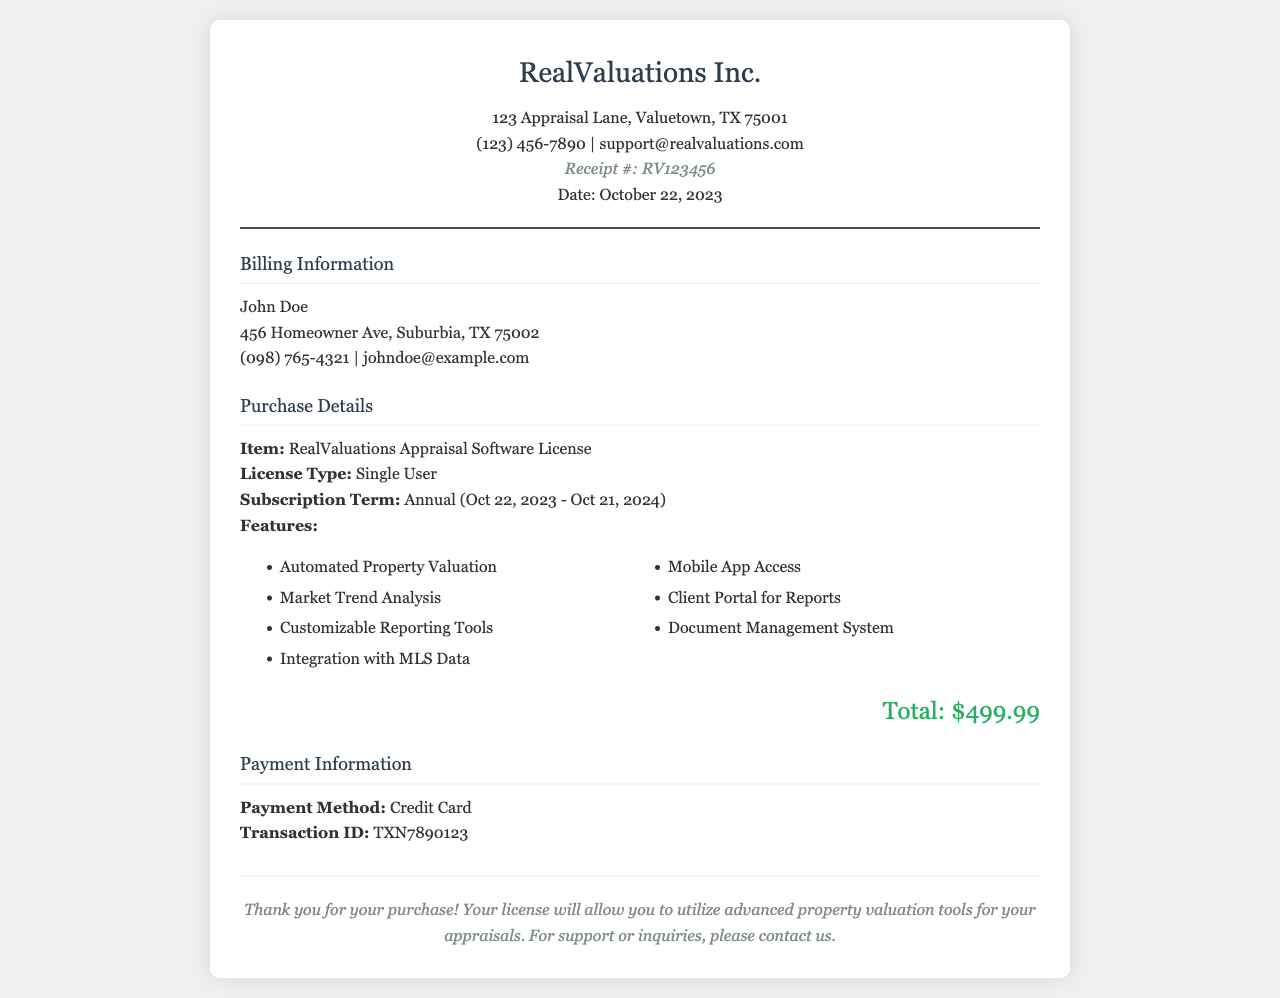What is the receipt number? The receipt number identifies the specific transaction within the company's records, which is RV123456.
Answer: RV123456 What is the total amount paid? The total amount paid shown in the document, representing the cost of the software license, is $499.99.
Answer: $499.99 Who is the billing information addressed to? The billing information lists the name of the individual responsible for the payment, which is John Doe.
Answer: John Doe What is the subscription term for the software? The subscription term defines the period for which the license is valid, stated as Annual (Oct 22, 2023 - Oct 21, 2024).
Answer: Annual (Oct 22, 2023 - Oct 21, 2024) What are the features included with the software? The features provide a list of functionalities available with the software license, including Automated Property Valuation and Market Trend Analysis.
Answer: Automated Property Valuation, Market Trend Analysis, Customizable Reporting Tools, Integration with MLS Data, Mobile App Access, Client Portal for Reports, Document Management System What payment method was used? The payment method indicates how the purchase was completed, specified as Credit Card in the document.
Answer: Credit Card What is the transaction ID? The transaction ID is a unique identifier for the payment processing which helps in reference, noted as TXN7890123.
Answer: TXN7890123 What company issued the receipt? The company name appears at the top of the receipt providing their identity, which is RealValuations Inc.
Answer: RealValuations Inc What date was the receipt issued? The date of issuance is recorded for tracking purposes, which is October 22, 2023.
Answer: October 22, 2023 